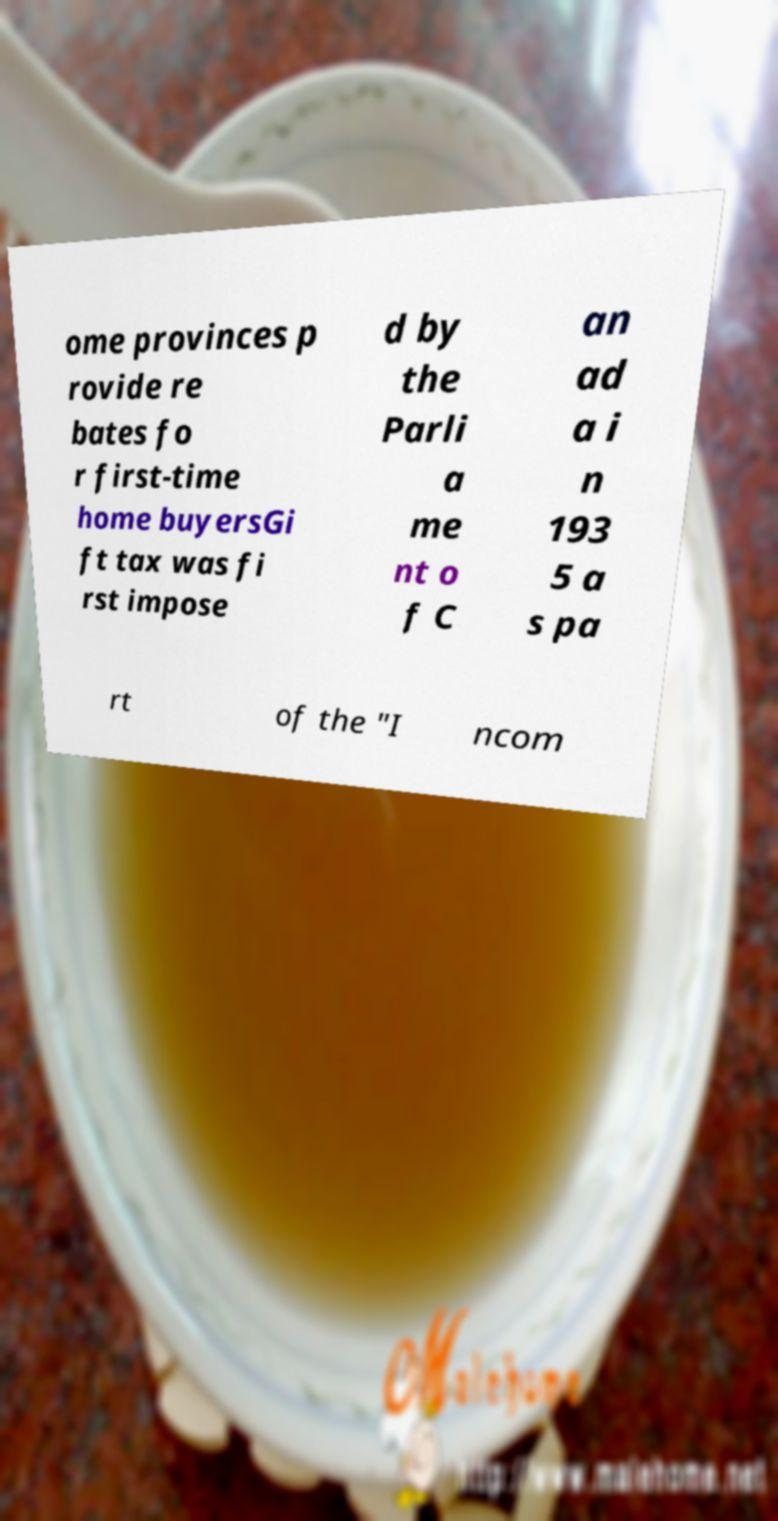Could you assist in decoding the text presented in this image and type it out clearly? ome provinces p rovide re bates fo r first-time home buyersGi ft tax was fi rst impose d by the Parli a me nt o f C an ad a i n 193 5 a s pa rt of the "I ncom 